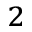Convert formula to latex. <formula><loc_0><loc_0><loc_500><loc_500>_ { 2 }</formula> 